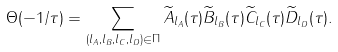Convert formula to latex. <formula><loc_0><loc_0><loc_500><loc_500>\Theta ( - 1 / \tau ) = \sum _ { ( l _ { A } , l _ { B } , l _ { C } , l _ { D } ) \in \Pi } \widetilde { A } _ { l _ { A } } ( \tau ) \widetilde { B } _ { l _ { B } } ( \tau ) \widetilde { C } _ { l _ { C } } ( \tau ) \widetilde { D } _ { l _ { D } } ( \tau ) .</formula> 